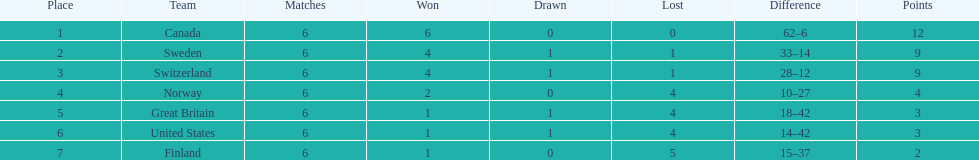Which team secured more victories, finland or norway? Norway. 